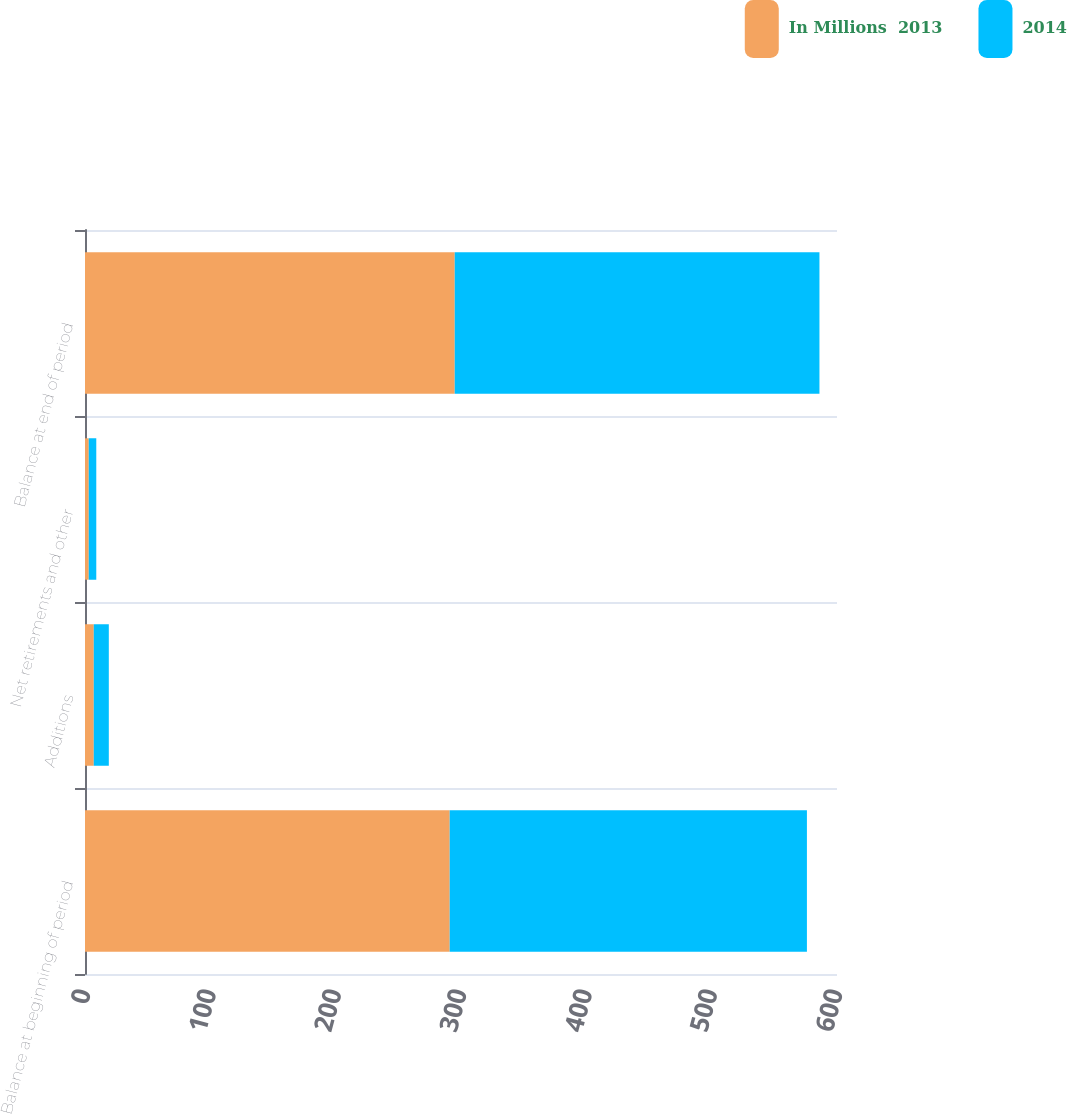<chart> <loc_0><loc_0><loc_500><loc_500><stacked_bar_chart><ecel><fcel>Balance at beginning of period<fcel>Additions<fcel>Net retirements and other<fcel>Balance at end of period<nl><fcel>In Millions  2013<fcel>291<fcel>7<fcel>3<fcel>295<nl><fcel>2014<fcel>285<fcel>12<fcel>6<fcel>291<nl></chart> 